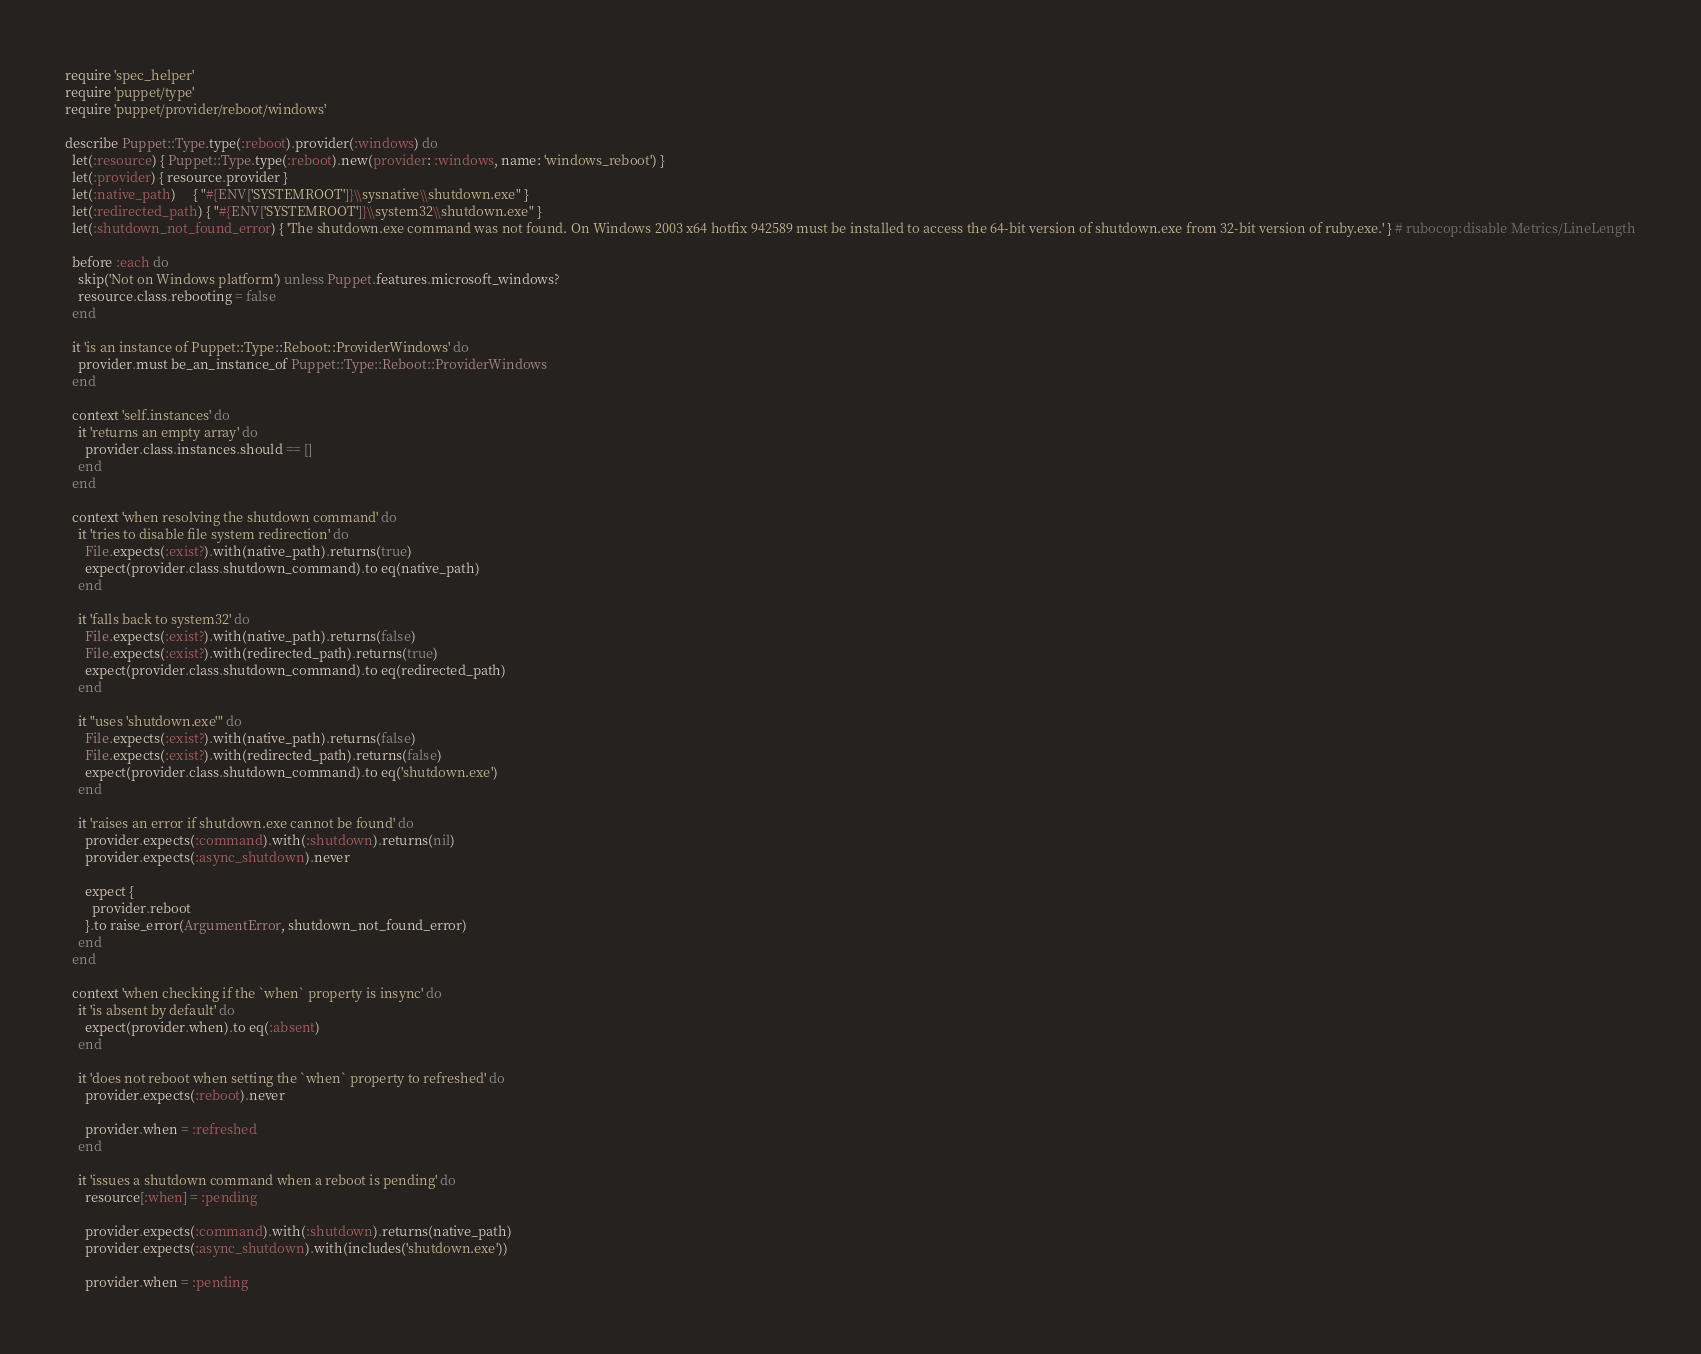Convert code to text. <code><loc_0><loc_0><loc_500><loc_500><_Ruby_>require 'spec_helper'
require 'puppet/type'
require 'puppet/provider/reboot/windows'

describe Puppet::Type.type(:reboot).provider(:windows) do
  let(:resource) { Puppet::Type.type(:reboot).new(provider: :windows, name: 'windows_reboot') }
  let(:provider) { resource.provider }
  let(:native_path)     { "#{ENV['SYSTEMROOT']}\\sysnative\\shutdown.exe" }
  let(:redirected_path) { "#{ENV['SYSTEMROOT']}\\system32\\shutdown.exe" }
  let(:shutdown_not_found_error) { 'The shutdown.exe command was not found. On Windows 2003 x64 hotfix 942589 must be installed to access the 64-bit version of shutdown.exe from 32-bit version of ruby.exe.' } # rubocop:disable Metrics/LineLength

  before :each do
    skip('Not on Windows platform') unless Puppet.features.microsoft_windows?
    resource.class.rebooting = false
  end

  it 'is an instance of Puppet::Type::Reboot::ProviderWindows' do
    provider.must be_an_instance_of Puppet::Type::Reboot::ProviderWindows
  end

  context 'self.instances' do
    it 'returns an empty array' do
      provider.class.instances.should == []
    end
  end

  context 'when resolving the shutdown command' do
    it 'tries to disable file system redirection' do
      File.expects(:exist?).with(native_path).returns(true)
      expect(provider.class.shutdown_command).to eq(native_path)
    end

    it 'falls back to system32' do
      File.expects(:exist?).with(native_path).returns(false)
      File.expects(:exist?).with(redirected_path).returns(true)
      expect(provider.class.shutdown_command).to eq(redirected_path)
    end

    it "uses 'shutdown.exe'" do
      File.expects(:exist?).with(native_path).returns(false)
      File.expects(:exist?).with(redirected_path).returns(false)
      expect(provider.class.shutdown_command).to eq('shutdown.exe')
    end

    it 'raises an error if shutdown.exe cannot be found' do
      provider.expects(:command).with(:shutdown).returns(nil)
      provider.expects(:async_shutdown).never

      expect {
        provider.reboot
      }.to raise_error(ArgumentError, shutdown_not_found_error)
    end
  end

  context 'when checking if the `when` property is insync' do
    it 'is absent by default' do
      expect(provider.when).to eq(:absent)
    end

    it 'does not reboot when setting the `when` property to refreshed' do
      provider.expects(:reboot).never

      provider.when = :refreshed
    end

    it 'issues a shutdown command when a reboot is pending' do
      resource[:when] = :pending

      provider.expects(:command).with(:shutdown).returns(native_path)
      provider.expects(:async_shutdown).with(includes('shutdown.exe'))

      provider.when = :pending</code> 